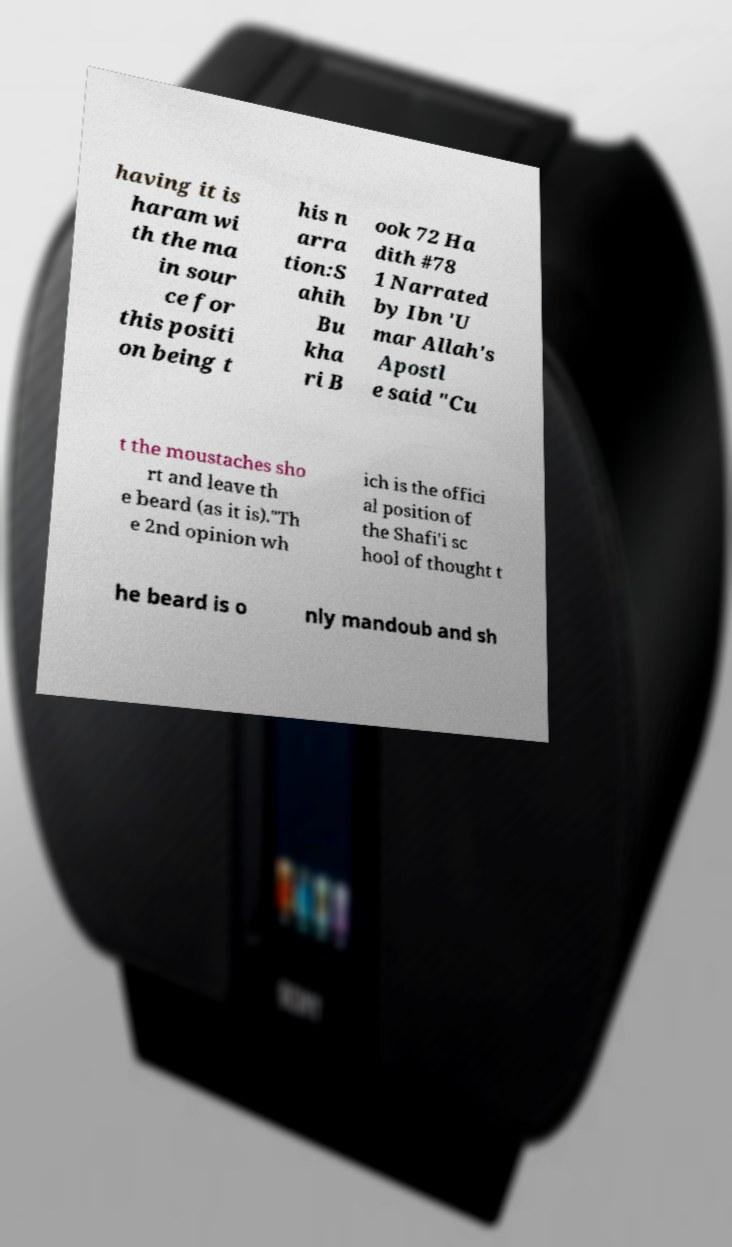Can you read and provide the text displayed in the image?This photo seems to have some interesting text. Can you extract and type it out for me? having it is haram wi th the ma in sour ce for this positi on being t his n arra tion:S ahih Bu kha ri B ook 72 Ha dith #78 1 Narrated by Ibn 'U mar Allah's Apostl e said "Cu t the moustaches sho rt and leave th e beard (as it is)."Th e 2nd opinion wh ich is the offici al position of the Shafi'i sc hool of thought t he beard is o nly mandoub and sh 